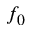<formula> <loc_0><loc_0><loc_500><loc_500>f _ { 0 }</formula> 